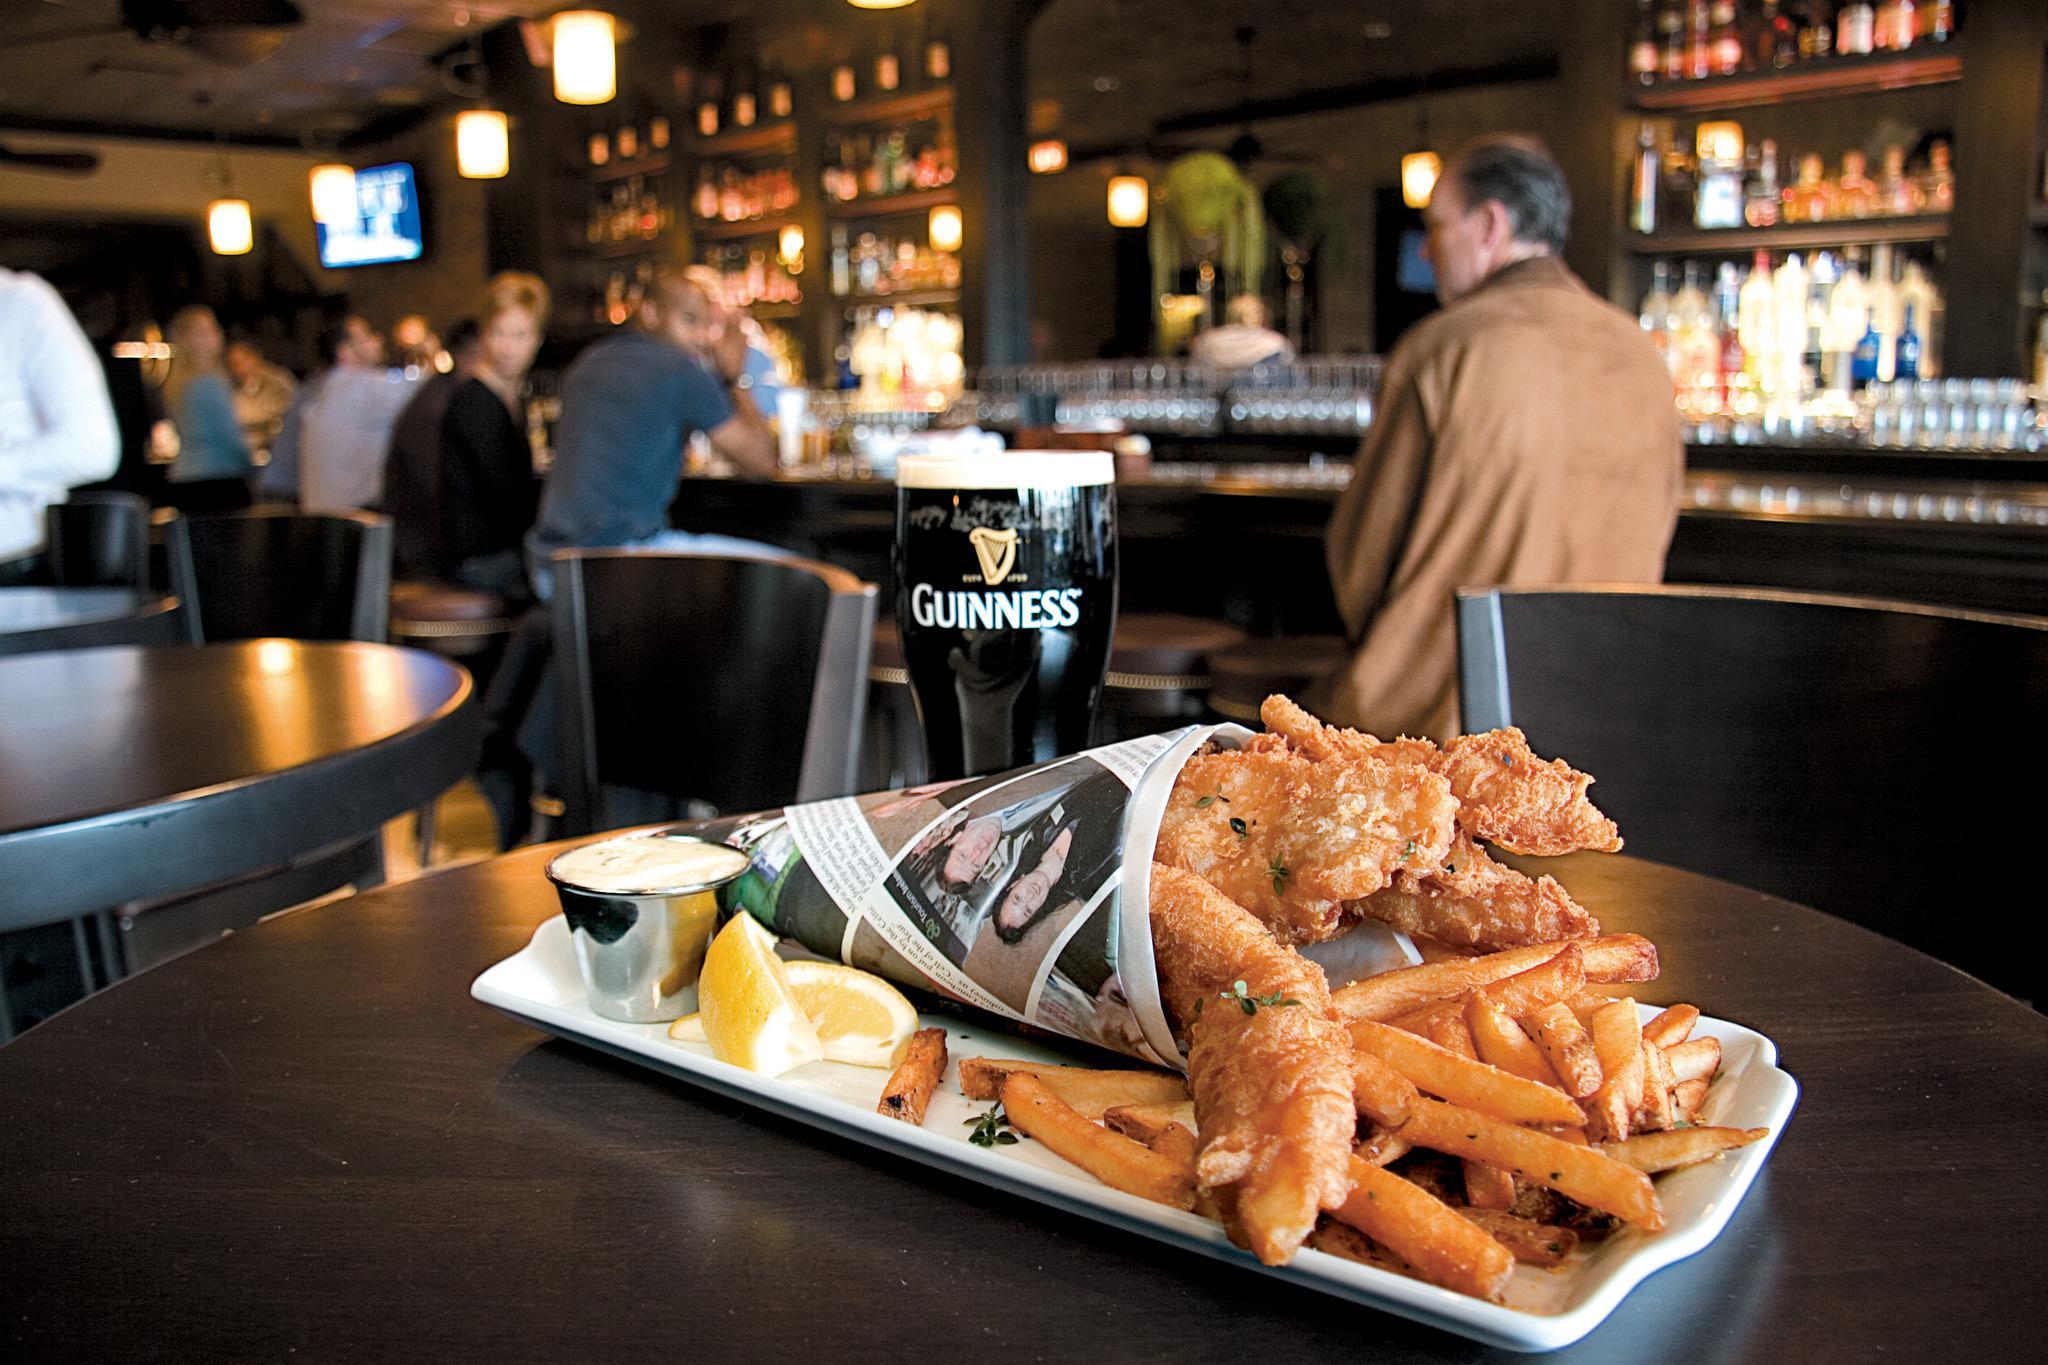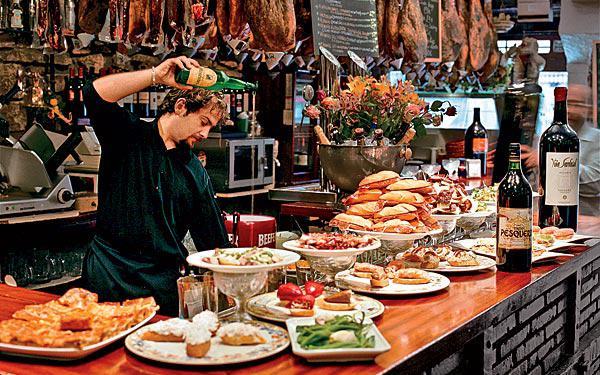The first image is the image on the left, the second image is the image on the right. For the images displayed, is the sentence "Hands are poised over a plate of food on a brown table holding multiple white plates in the right image." factually correct? Answer yes or no. No. 